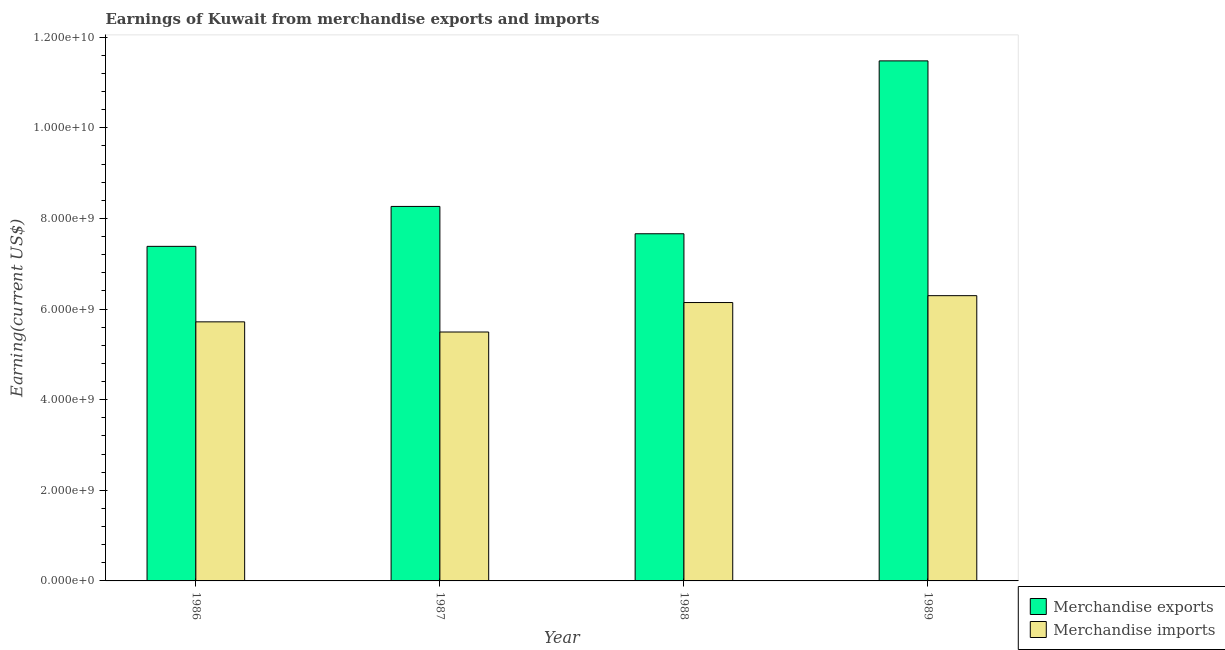How many different coloured bars are there?
Your answer should be very brief. 2. Are the number of bars on each tick of the X-axis equal?
Your answer should be very brief. Yes. What is the earnings from merchandise exports in 1986?
Make the answer very short. 7.38e+09. Across all years, what is the maximum earnings from merchandise imports?
Keep it short and to the point. 6.30e+09. Across all years, what is the minimum earnings from merchandise imports?
Provide a succinct answer. 5.49e+09. What is the total earnings from merchandise exports in the graph?
Ensure brevity in your answer.  3.48e+1. What is the difference between the earnings from merchandise imports in 1986 and that in 1989?
Provide a succinct answer. -5.78e+08. What is the difference between the earnings from merchandise exports in 1988 and the earnings from merchandise imports in 1987?
Give a very brief answer. -6.03e+08. What is the average earnings from merchandise exports per year?
Provide a succinct answer. 8.70e+09. In the year 1987, what is the difference between the earnings from merchandise imports and earnings from merchandise exports?
Keep it short and to the point. 0. What is the ratio of the earnings from merchandise imports in 1986 to that in 1988?
Give a very brief answer. 0.93. Is the earnings from merchandise imports in 1986 less than that in 1987?
Make the answer very short. No. What is the difference between the highest and the second highest earnings from merchandise imports?
Your answer should be very brief. 1.52e+08. What is the difference between the highest and the lowest earnings from merchandise exports?
Your answer should be very brief. 4.09e+09. What does the 1st bar from the left in 1989 represents?
Your response must be concise. Merchandise exports. What does the 2nd bar from the right in 1987 represents?
Ensure brevity in your answer.  Merchandise exports. Are all the bars in the graph horizontal?
Ensure brevity in your answer.  No. How many years are there in the graph?
Your response must be concise. 4. Does the graph contain any zero values?
Your response must be concise. No. Does the graph contain grids?
Offer a very short reply. No. Where does the legend appear in the graph?
Provide a succinct answer. Bottom right. How are the legend labels stacked?
Your answer should be very brief. Vertical. What is the title of the graph?
Offer a terse response. Earnings of Kuwait from merchandise exports and imports. What is the label or title of the Y-axis?
Your response must be concise. Earning(current US$). What is the Earning(current US$) of Merchandise exports in 1986?
Your answer should be compact. 7.38e+09. What is the Earning(current US$) of Merchandise imports in 1986?
Make the answer very short. 5.72e+09. What is the Earning(current US$) in Merchandise exports in 1987?
Make the answer very short. 8.26e+09. What is the Earning(current US$) in Merchandise imports in 1987?
Provide a succinct answer. 5.49e+09. What is the Earning(current US$) in Merchandise exports in 1988?
Provide a succinct answer. 7.66e+09. What is the Earning(current US$) of Merchandise imports in 1988?
Make the answer very short. 6.14e+09. What is the Earning(current US$) of Merchandise exports in 1989?
Your response must be concise. 1.15e+1. What is the Earning(current US$) in Merchandise imports in 1989?
Offer a terse response. 6.30e+09. Across all years, what is the maximum Earning(current US$) in Merchandise exports?
Provide a succinct answer. 1.15e+1. Across all years, what is the maximum Earning(current US$) of Merchandise imports?
Your response must be concise. 6.30e+09. Across all years, what is the minimum Earning(current US$) in Merchandise exports?
Offer a very short reply. 7.38e+09. Across all years, what is the minimum Earning(current US$) of Merchandise imports?
Your response must be concise. 5.49e+09. What is the total Earning(current US$) in Merchandise exports in the graph?
Your response must be concise. 3.48e+1. What is the total Earning(current US$) of Merchandise imports in the graph?
Offer a very short reply. 2.36e+1. What is the difference between the Earning(current US$) in Merchandise exports in 1986 and that in 1987?
Make the answer very short. -8.81e+08. What is the difference between the Earning(current US$) of Merchandise imports in 1986 and that in 1987?
Your response must be concise. 2.24e+08. What is the difference between the Earning(current US$) of Merchandise exports in 1986 and that in 1988?
Keep it short and to the point. -2.78e+08. What is the difference between the Earning(current US$) in Merchandise imports in 1986 and that in 1988?
Your answer should be compact. -4.26e+08. What is the difference between the Earning(current US$) in Merchandise exports in 1986 and that in 1989?
Make the answer very short. -4.09e+09. What is the difference between the Earning(current US$) in Merchandise imports in 1986 and that in 1989?
Your answer should be compact. -5.78e+08. What is the difference between the Earning(current US$) of Merchandise exports in 1987 and that in 1988?
Offer a terse response. 6.03e+08. What is the difference between the Earning(current US$) of Merchandise imports in 1987 and that in 1988?
Your answer should be compact. -6.50e+08. What is the difference between the Earning(current US$) in Merchandise exports in 1987 and that in 1989?
Offer a very short reply. -3.21e+09. What is the difference between the Earning(current US$) in Merchandise imports in 1987 and that in 1989?
Your answer should be compact. -8.02e+08. What is the difference between the Earning(current US$) of Merchandise exports in 1988 and that in 1989?
Your response must be concise. -3.82e+09. What is the difference between the Earning(current US$) in Merchandise imports in 1988 and that in 1989?
Make the answer very short. -1.52e+08. What is the difference between the Earning(current US$) of Merchandise exports in 1986 and the Earning(current US$) of Merchandise imports in 1987?
Ensure brevity in your answer.  1.89e+09. What is the difference between the Earning(current US$) of Merchandise exports in 1986 and the Earning(current US$) of Merchandise imports in 1988?
Provide a succinct answer. 1.24e+09. What is the difference between the Earning(current US$) in Merchandise exports in 1986 and the Earning(current US$) in Merchandise imports in 1989?
Ensure brevity in your answer.  1.09e+09. What is the difference between the Earning(current US$) of Merchandise exports in 1987 and the Earning(current US$) of Merchandise imports in 1988?
Offer a terse response. 2.12e+09. What is the difference between the Earning(current US$) of Merchandise exports in 1987 and the Earning(current US$) of Merchandise imports in 1989?
Provide a short and direct response. 1.97e+09. What is the difference between the Earning(current US$) of Merchandise exports in 1988 and the Earning(current US$) of Merchandise imports in 1989?
Your answer should be very brief. 1.37e+09. What is the average Earning(current US$) in Merchandise exports per year?
Offer a terse response. 8.70e+09. What is the average Earning(current US$) in Merchandise imports per year?
Give a very brief answer. 5.91e+09. In the year 1986, what is the difference between the Earning(current US$) in Merchandise exports and Earning(current US$) in Merchandise imports?
Offer a terse response. 1.67e+09. In the year 1987, what is the difference between the Earning(current US$) of Merchandise exports and Earning(current US$) of Merchandise imports?
Your response must be concise. 2.77e+09. In the year 1988, what is the difference between the Earning(current US$) in Merchandise exports and Earning(current US$) in Merchandise imports?
Keep it short and to the point. 1.52e+09. In the year 1989, what is the difference between the Earning(current US$) of Merchandise exports and Earning(current US$) of Merchandise imports?
Provide a succinct answer. 5.18e+09. What is the ratio of the Earning(current US$) of Merchandise exports in 1986 to that in 1987?
Provide a short and direct response. 0.89. What is the ratio of the Earning(current US$) in Merchandise imports in 1986 to that in 1987?
Your response must be concise. 1.04. What is the ratio of the Earning(current US$) in Merchandise exports in 1986 to that in 1988?
Offer a very short reply. 0.96. What is the ratio of the Earning(current US$) in Merchandise imports in 1986 to that in 1988?
Give a very brief answer. 0.93. What is the ratio of the Earning(current US$) in Merchandise exports in 1986 to that in 1989?
Your response must be concise. 0.64. What is the ratio of the Earning(current US$) in Merchandise imports in 1986 to that in 1989?
Provide a short and direct response. 0.91. What is the ratio of the Earning(current US$) in Merchandise exports in 1987 to that in 1988?
Offer a very short reply. 1.08. What is the ratio of the Earning(current US$) of Merchandise imports in 1987 to that in 1988?
Give a very brief answer. 0.89. What is the ratio of the Earning(current US$) of Merchandise exports in 1987 to that in 1989?
Make the answer very short. 0.72. What is the ratio of the Earning(current US$) in Merchandise imports in 1987 to that in 1989?
Provide a succinct answer. 0.87. What is the ratio of the Earning(current US$) of Merchandise exports in 1988 to that in 1989?
Offer a very short reply. 0.67. What is the ratio of the Earning(current US$) in Merchandise imports in 1988 to that in 1989?
Offer a very short reply. 0.98. What is the difference between the highest and the second highest Earning(current US$) in Merchandise exports?
Provide a short and direct response. 3.21e+09. What is the difference between the highest and the second highest Earning(current US$) in Merchandise imports?
Keep it short and to the point. 1.52e+08. What is the difference between the highest and the lowest Earning(current US$) of Merchandise exports?
Your answer should be very brief. 4.09e+09. What is the difference between the highest and the lowest Earning(current US$) of Merchandise imports?
Your answer should be compact. 8.02e+08. 